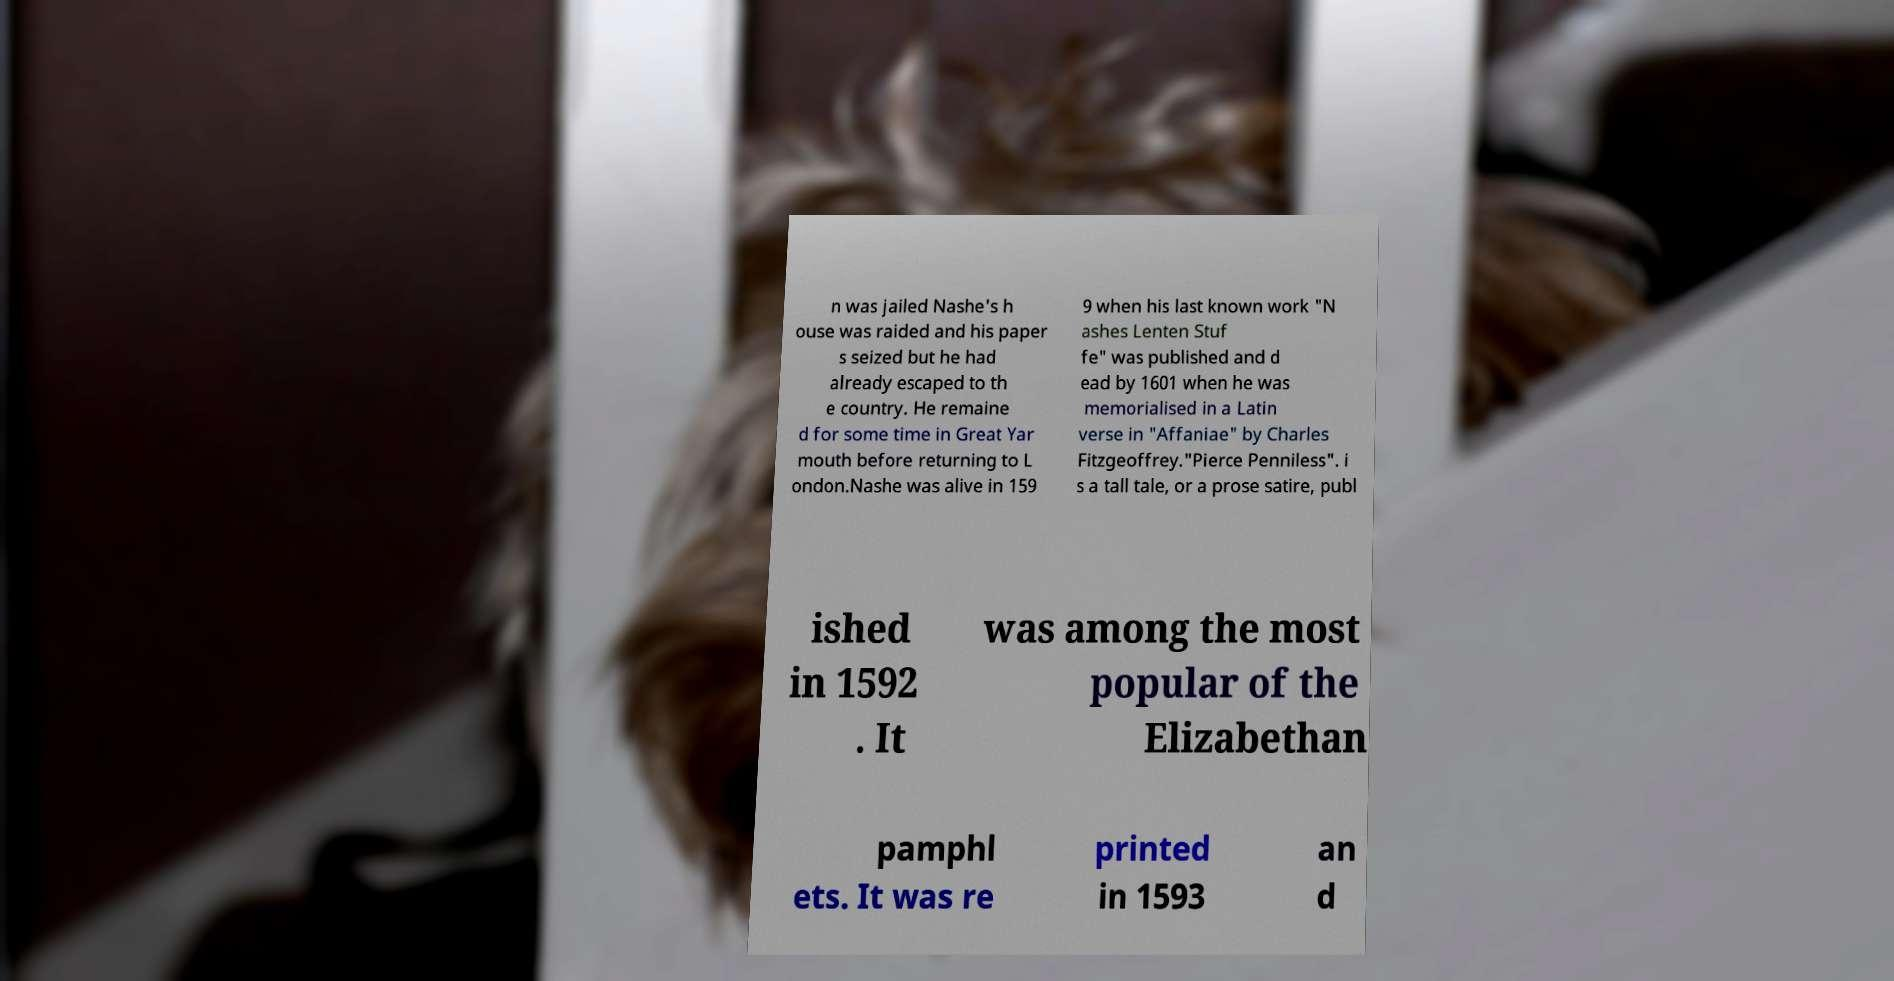Could you assist in decoding the text presented in this image and type it out clearly? n was jailed Nashe's h ouse was raided and his paper s seized but he had already escaped to th e country. He remaine d for some time in Great Yar mouth before returning to L ondon.Nashe was alive in 159 9 when his last known work "N ashes Lenten Stuf fe" was published and d ead by 1601 when he was memorialised in a Latin verse in "Affaniae" by Charles Fitzgeoffrey."Pierce Penniless". i s a tall tale, or a prose satire, publ ished in 1592 . It was among the most popular of the Elizabethan pamphl ets. It was re printed in 1593 an d 